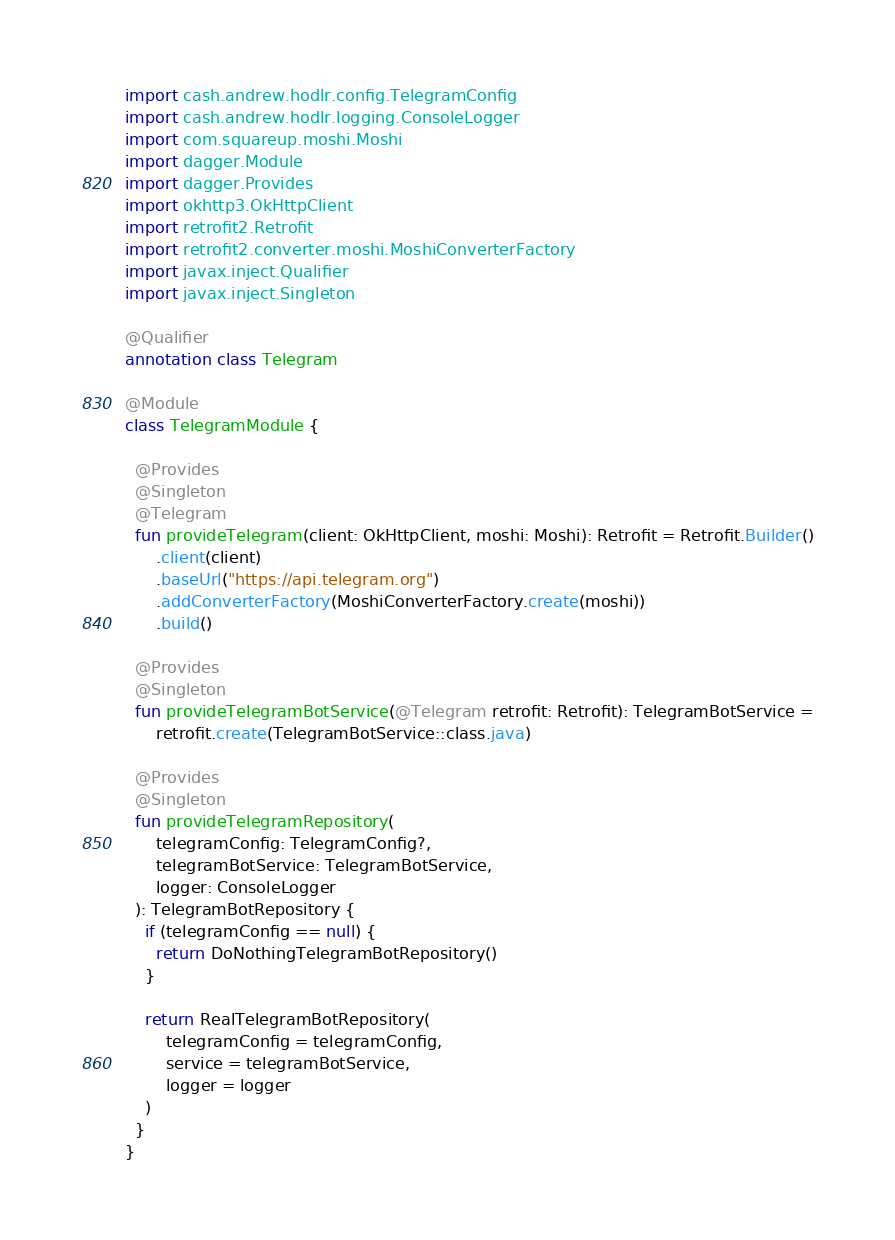<code> <loc_0><loc_0><loc_500><loc_500><_Kotlin_>import cash.andrew.hodlr.config.TelegramConfig
import cash.andrew.hodlr.logging.ConsoleLogger
import com.squareup.moshi.Moshi
import dagger.Module
import dagger.Provides
import okhttp3.OkHttpClient
import retrofit2.Retrofit
import retrofit2.converter.moshi.MoshiConverterFactory
import javax.inject.Qualifier
import javax.inject.Singleton

@Qualifier
annotation class Telegram

@Module
class TelegramModule {

  @Provides
  @Singleton
  @Telegram
  fun provideTelegram(client: OkHttpClient, moshi: Moshi): Retrofit = Retrofit.Builder()
      .client(client)
      .baseUrl("https://api.telegram.org")
      .addConverterFactory(MoshiConverterFactory.create(moshi))
      .build()

  @Provides
  @Singleton
  fun provideTelegramBotService(@Telegram retrofit: Retrofit): TelegramBotService =
      retrofit.create(TelegramBotService::class.java)

  @Provides
  @Singleton
  fun provideTelegramRepository(
      telegramConfig: TelegramConfig?,
      telegramBotService: TelegramBotService,
      logger: ConsoleLogger
  ): TelegramBotRepository {
    if (telegramConfig == null) {
      return DoNothingTelegramBotRepository()
    }

    return RealTelegramBotRepository(
        telegramConfig = telegramConfig,
        service = telegramBotService,
        logger = logger
    )
  }
}
</code> 